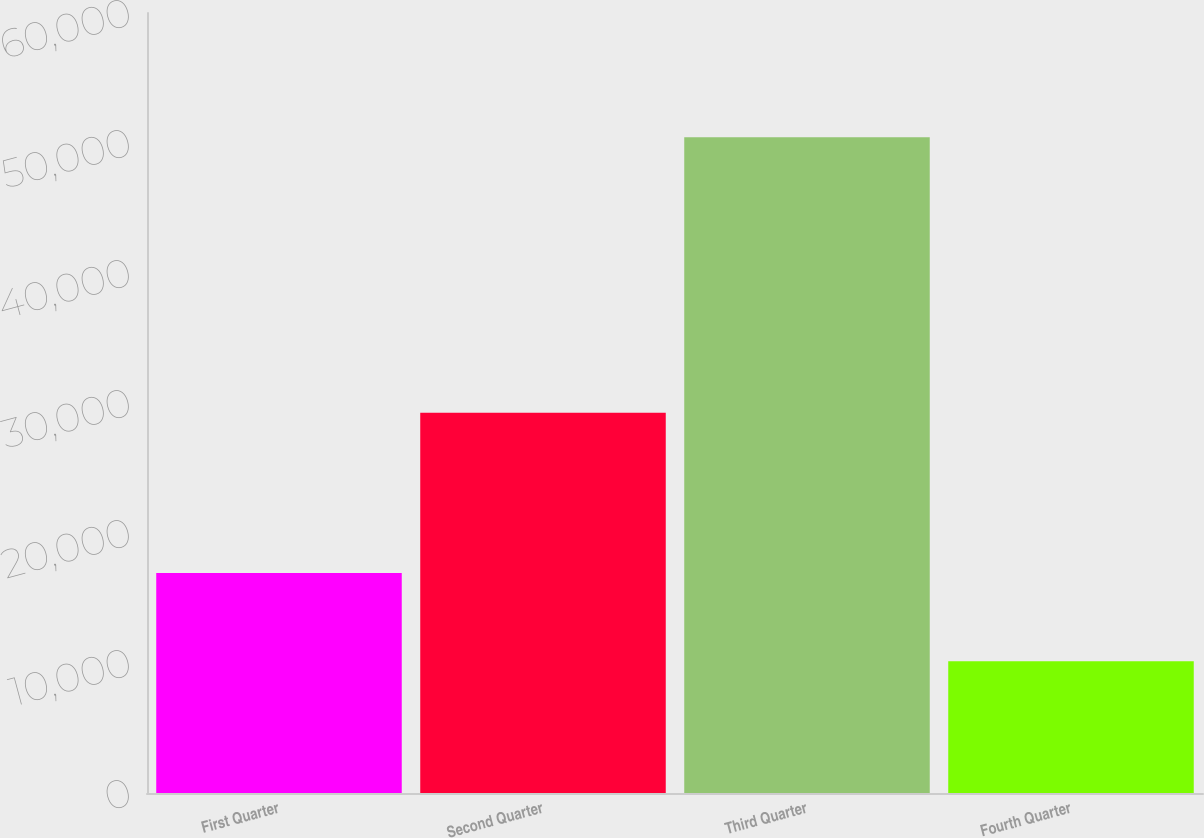Convert chart to OTSL. <chart><loc_0><loc_0><loc_500><loc_500><bar_chart><fcel>First Quarter<fcel>Second Quarter<fcel>Third Quarter<fcel>Fourth Quarter<nl><fcel>16928<fcel>29253<fcel>50451<fcel>10134<nl></chart> 